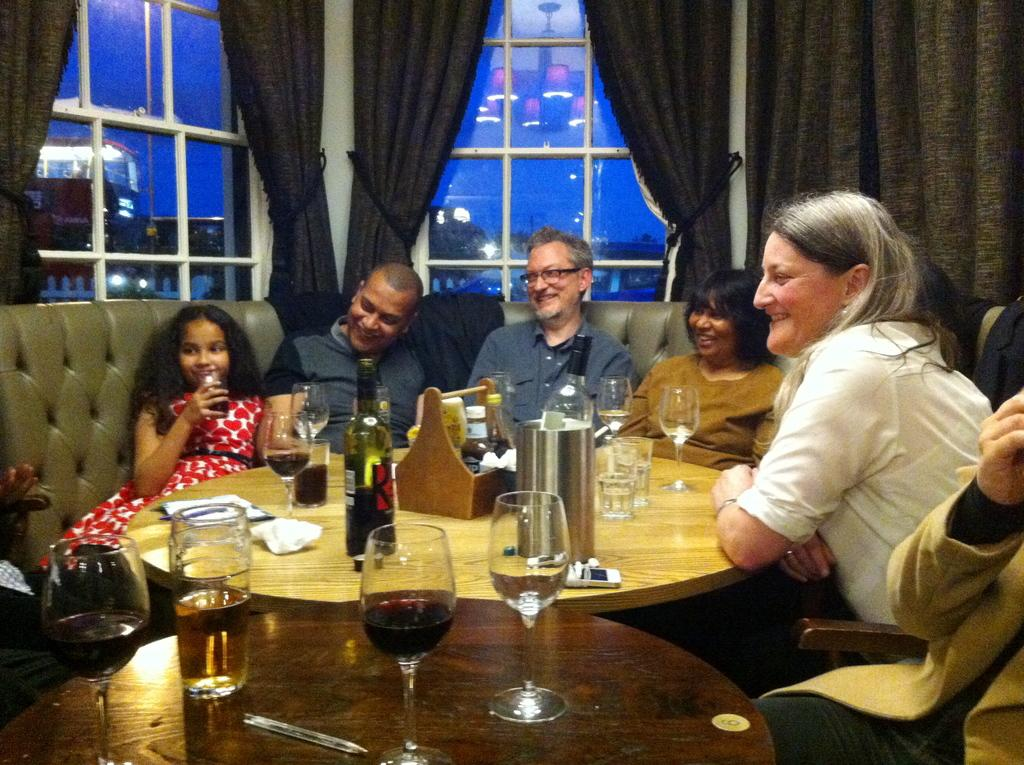What are the family members doing in the image? Family members are sitting around a table in the image. What items can be seen on the table? There are wine bottles and glasses on the table. What can be seen in the background of the image? There are windows and curtains in the background. What type of straw is being used by the carpenter in the image? There is no carpenter or straw present in the image. The image features family members sitting around a table with wine bottles and glasses. 